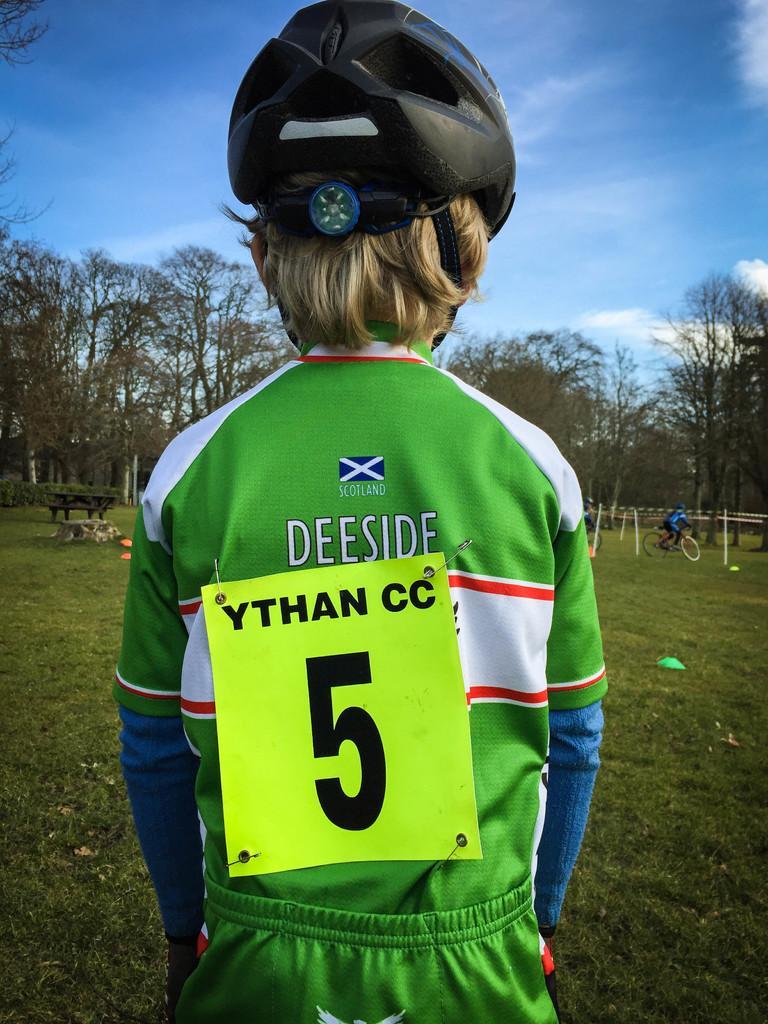Can you describe this image briefly? In the center of the image we can see person standing and wearing a helmet. On the right there is a person riding a bicycle. On the left we can see a bench. In the background there are trees and sky. 